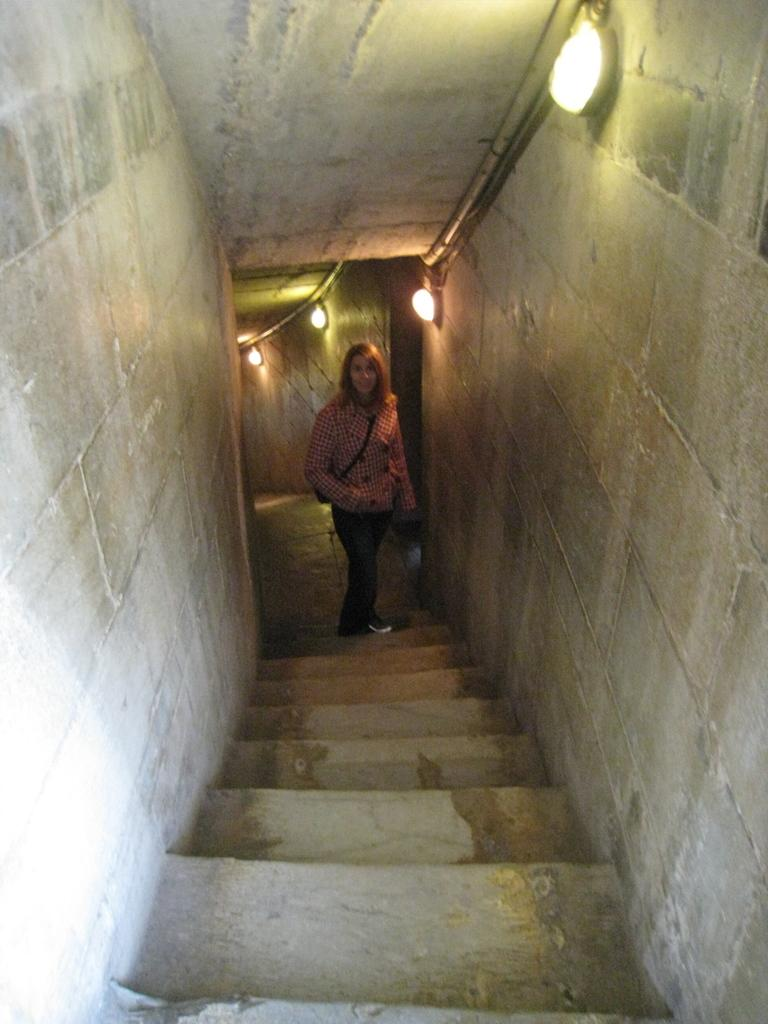Who is the main subject in the image? There is a lady standing in the center of the image. What architectural feature can be seen in the image? There are stairs in the image. What type of structures are visible in the background? There are walls in the background of the image. What can be seen illuminating the background? There are lights visible in the background of the image. What type of tank is visible in the image? There is no tank present in the image. What book is the lady holding in the image? The lady is not holding a book in the image. 